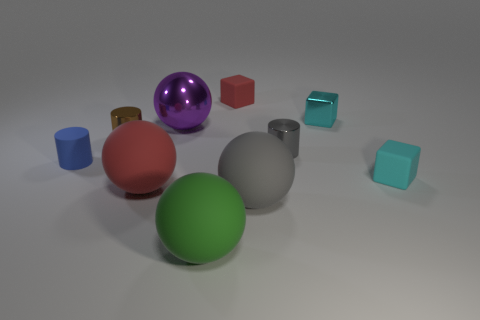Subtract all brown shiny cylinders. How many cylinders are left? 2 Subtract all cyan balls. How many cyan blocks are left? 2 Subtract all gray balls. How many balls are left? 3 Subtract 1 spheres. How many spheres are left? 3 Add 5 green matte spheres. How many green matte spheres exist? 6 Subtract 1 red spheres. How many objects are left? 9 Subtract all cubes. How many objects are left? 7 Subtract all cyan cylinders. Subtract all brown balls. How many cylinders are left? 3 Subtract all big purple things. Subtract all big red rubber balls. How many objects are left? 8 Add 2 gray metallic things. How many gray metallic things are left? 3 